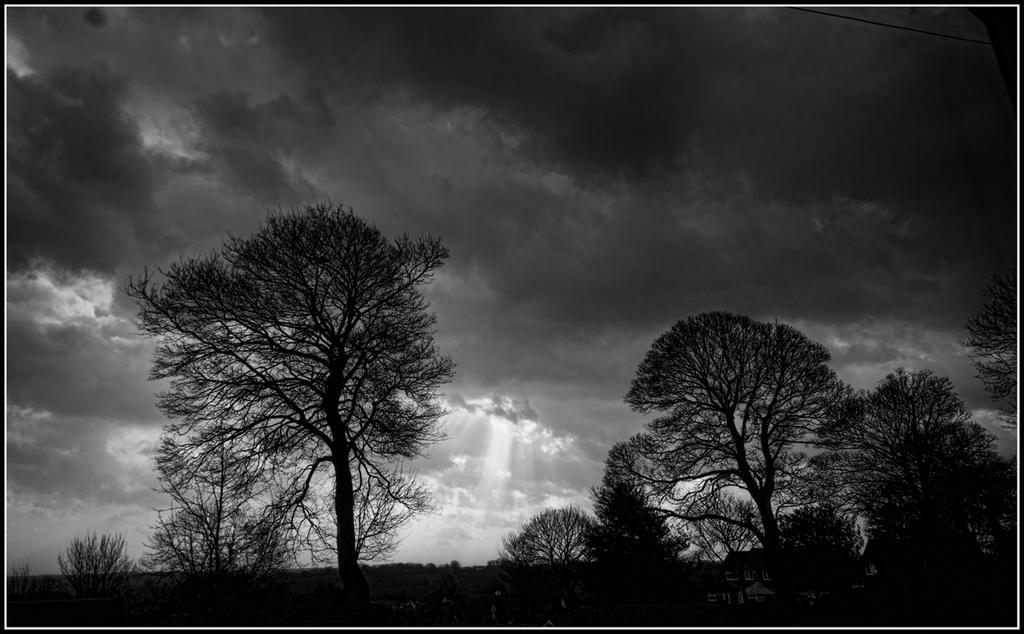Please provide a concise description of this image. In the picture I can see trees. In the background I can see the sky. This picture is black and white in color. 